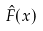<formula> <loc_0><loc_0><loc_500><loc_500>\hat { F } ( x )</formula> 